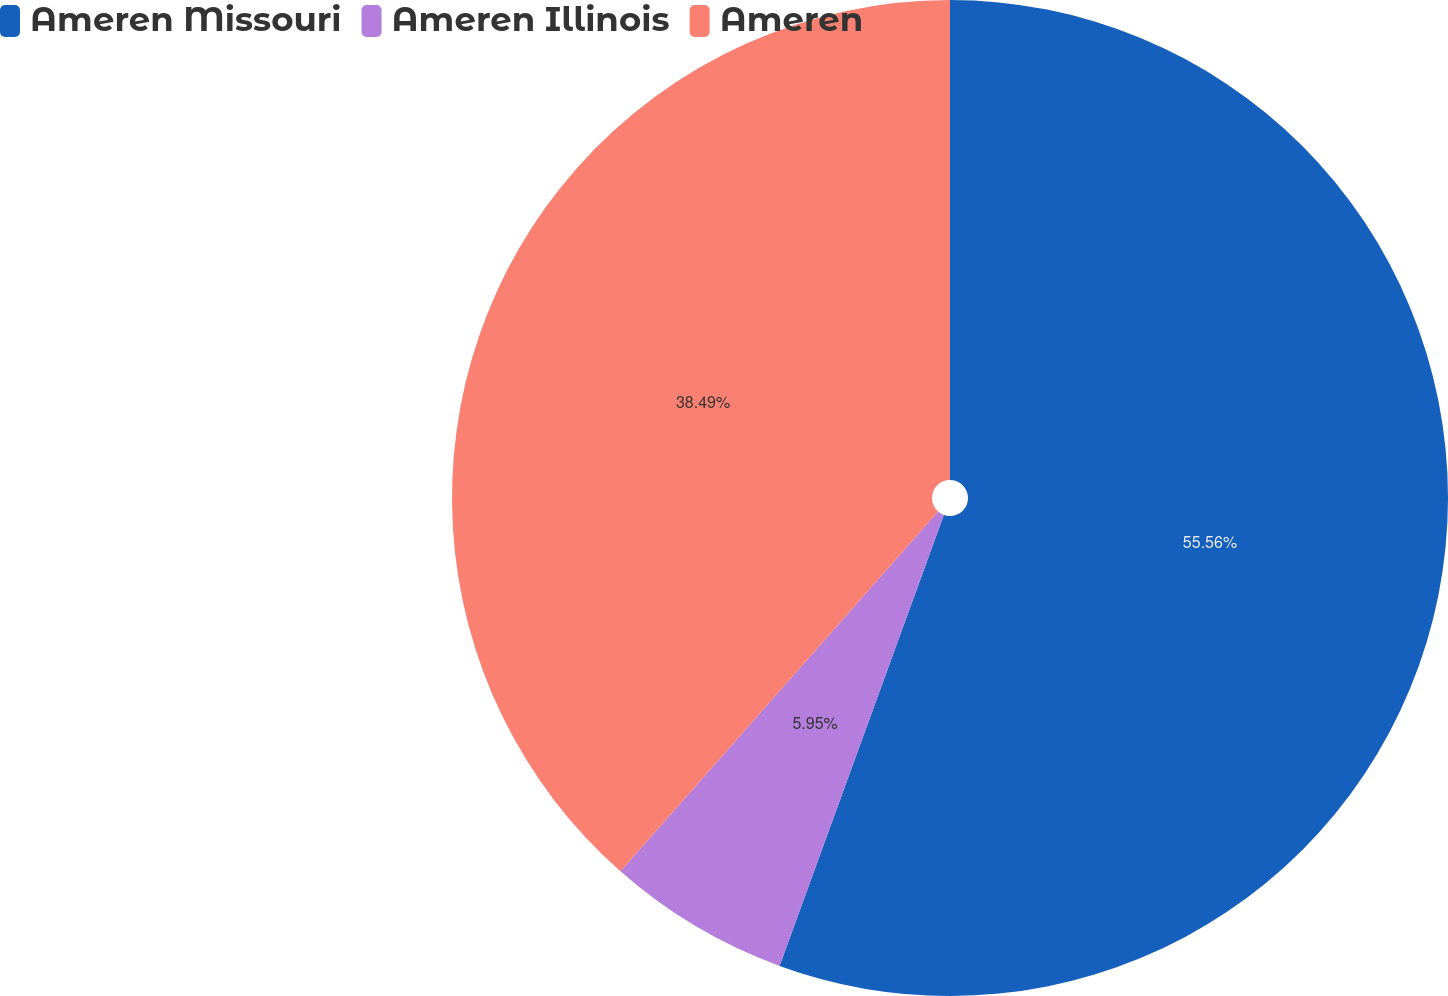Convert chart. <chart><loc_0><loc_0><loc_500><loc_500><pie_chart><fcel>Ameren Missouri<fcel>Ameren Illinois<fcel>Ameren<nl><fcel>55.56%<fcel>5.95%<fcel>38.49%<nl></chart> 